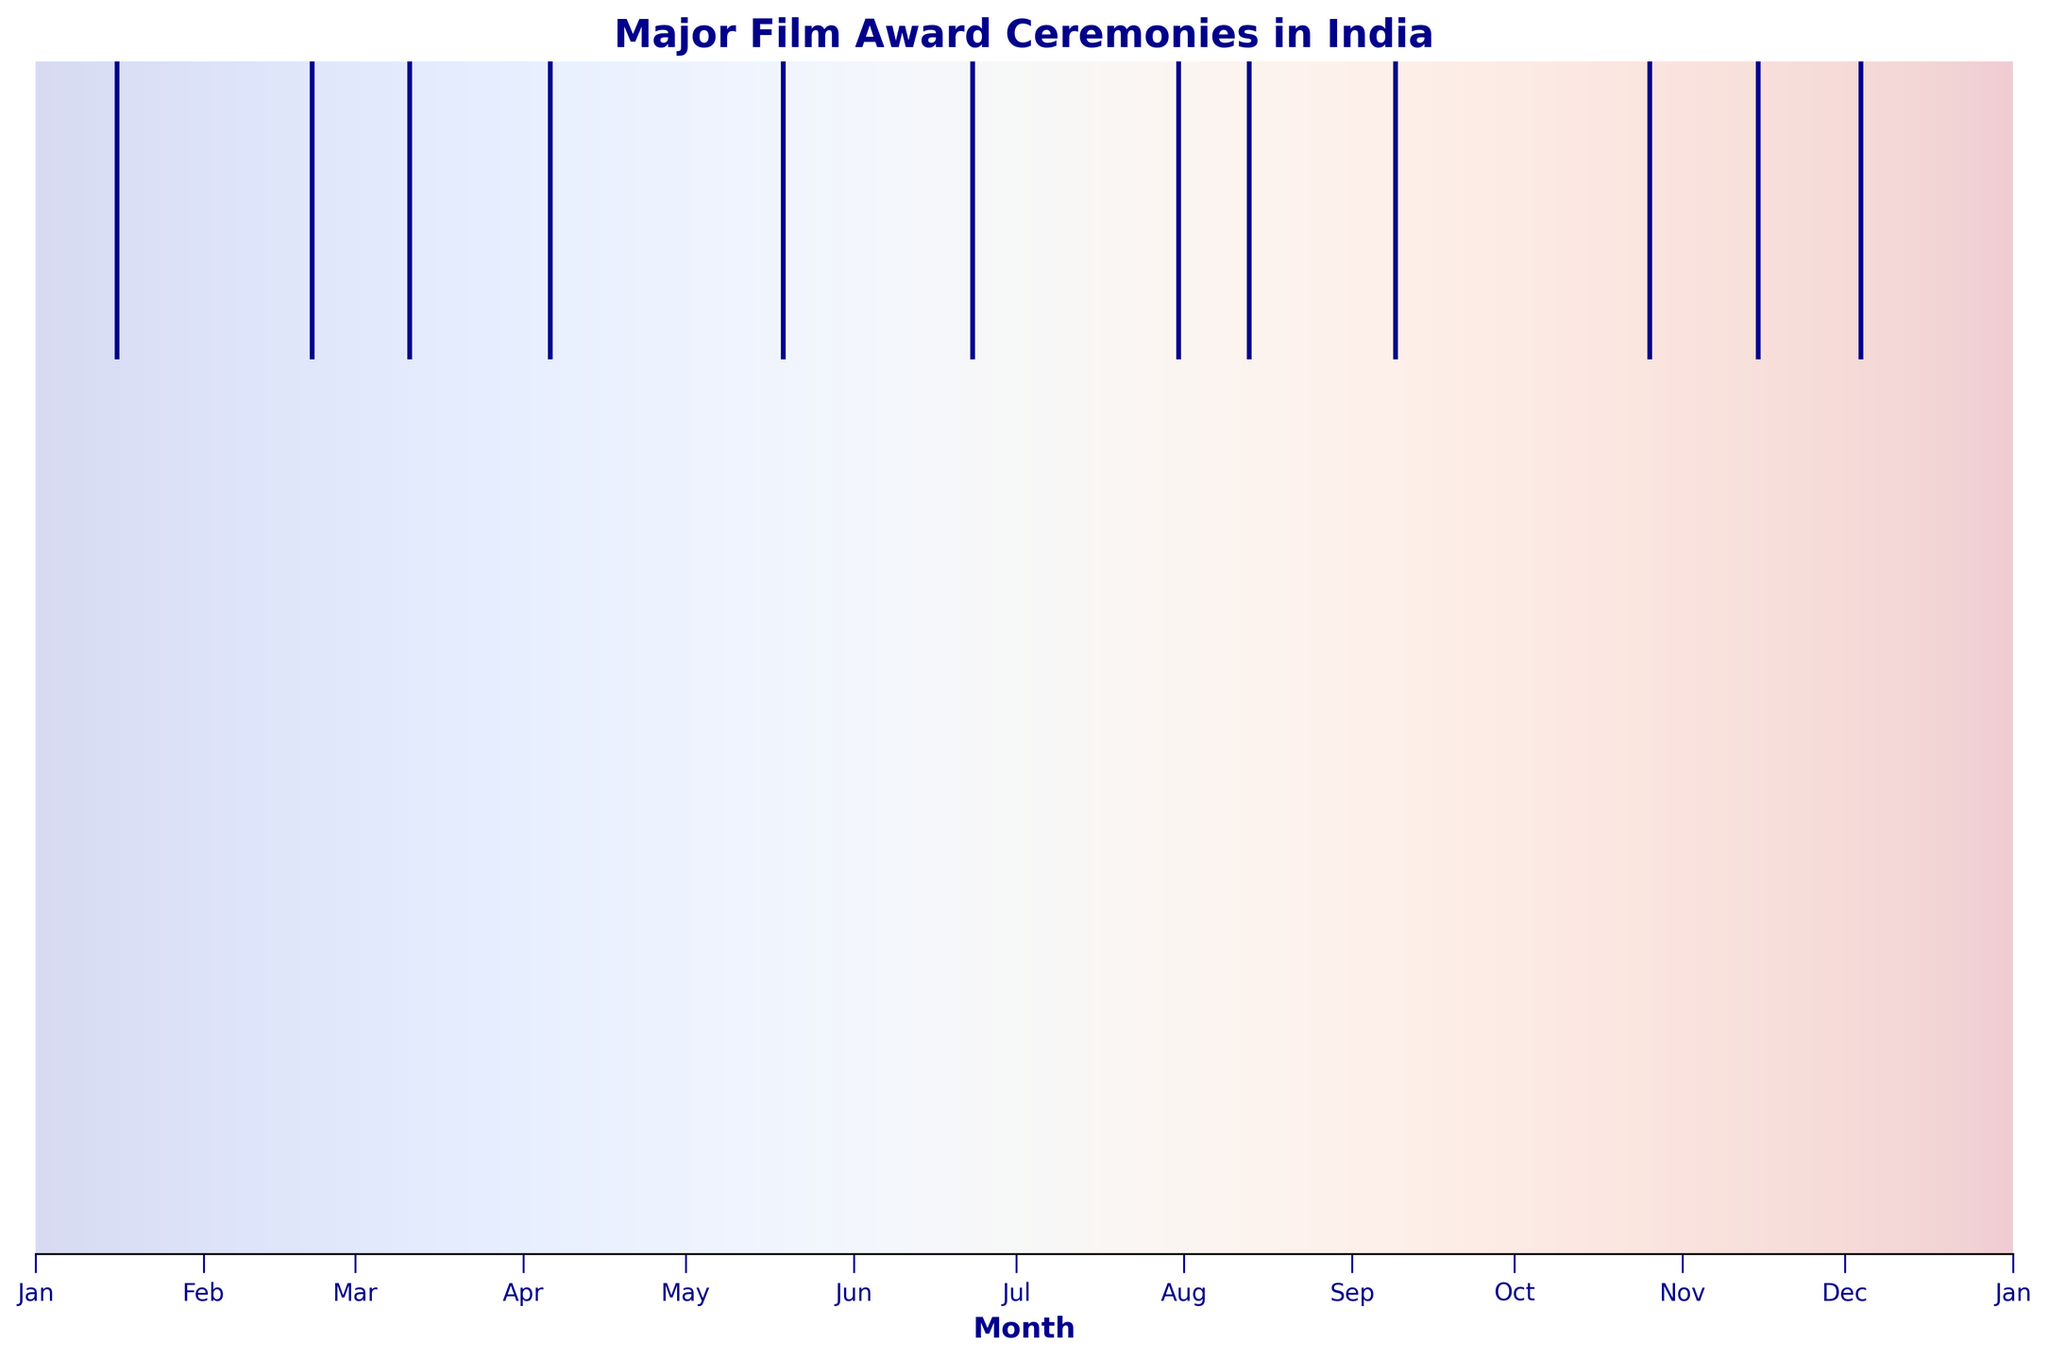When is the Filmfare Awards ceremony usually held? The Filmfare Awards ceremony is represented as an annotation in the figure. The annotation indicates that it is held in January.
Answer: January Which event is held in the middle of the year? By examining the figure, we see that there is a single annotation around the midpoint of the x-axis, which represents June. This event is the Tamil Nadu State Film Awards.
Answer: Tamil Nadu State Film Awards How many events are held in the first half of the year? We look at the annotations situated from January to June on the x-axis. The events are: Filmfare Awards, National Film Awards, Kerala State Film Awards, Bengal Film Journalists' Association Awards, and International Indian Film Academy Awards (IIFA). That's five events.
Answer: 5 Which month has the highest frequency of events? We observe the distribution and count the number of events in each month. September has the most events with a total of two events (Apsara Film & Television Producers Guild Awards, Screen Awards).
Answer: September What is the last event of the year? The figure shows an annotation for the Stardust Awards towards the far right end of the x-axis, indicating that it is the last event in December.
Answer: Stardust Awards Are there more events held in the first quarter (January to March) or the last quarter (October to December) of the year? First, count the events in January to March: Filmfare Awards, National Film Awards, Kerala State Film Awards (3 events). Then, count the events in October to December: Screen Awards, Zee Cine Awards, Stardust Awards (3 events). Both quarters have the same number of events.
Answer: Equal List all the awards held in the third quarter (July to September). Identify the events between July and September along the x-axis. They are: South Indian International Movie Awards (SIIMA), Vijay Awards, and Apsara Film & Television Producers Guild Awards.
Answer: South Indian International Movie Awards (SIIMA), Vijay Awards, Apsara Film & Television Producers Guild Awards What is the duration (in months) between the Filmfare Awards and the Screen Awards? The Filmfare Awards are in January, and the Screen Awards are in October. Calculating the difference in months: October - January = 9 months.
Answer: 9 months Compare the frequency of events in the first half of the year to the second half. First, count the events from January to June (5 events) and from July to December (7 events). The second half has more events.
Answer: Second half 